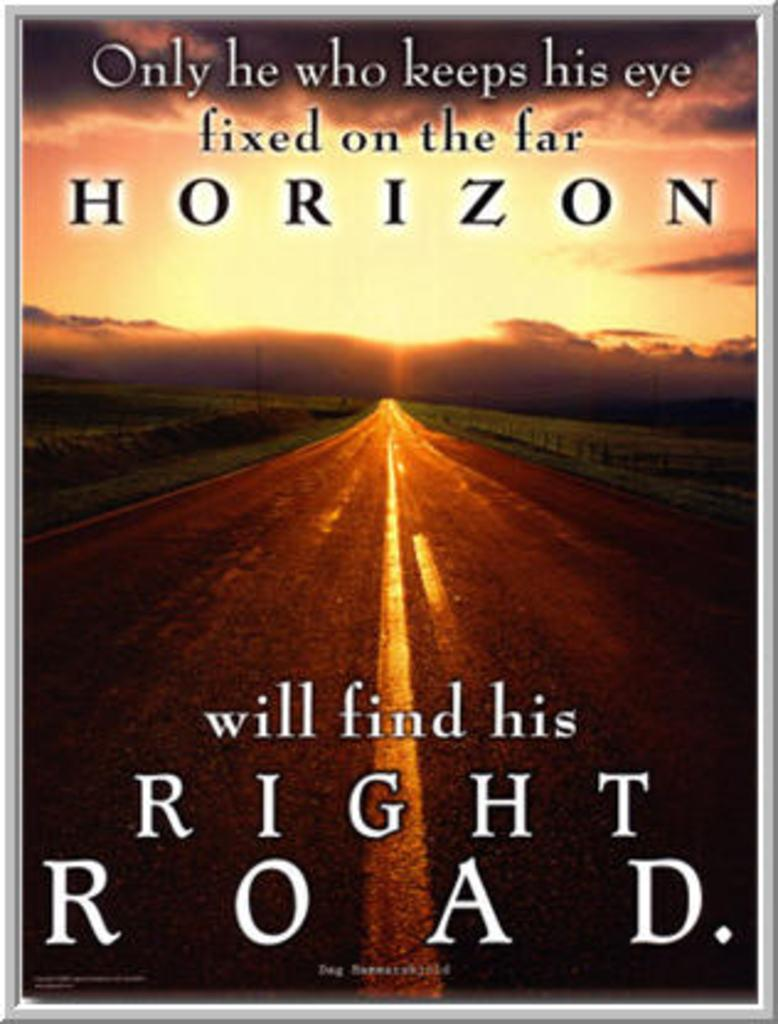<image>
Provide a brief description of the given image. An inspirational quote with matching scenary reminds us how to find the right road. 